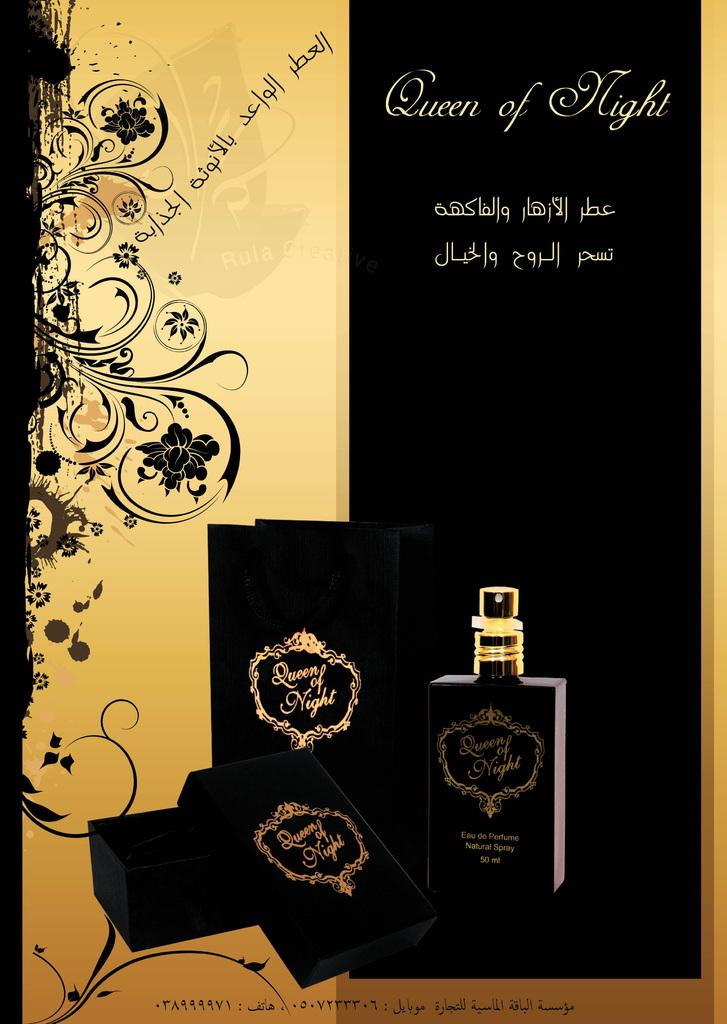<image>
Render a clear and concise summary of the photo. An ad for a perfume called Queen Of Night. 